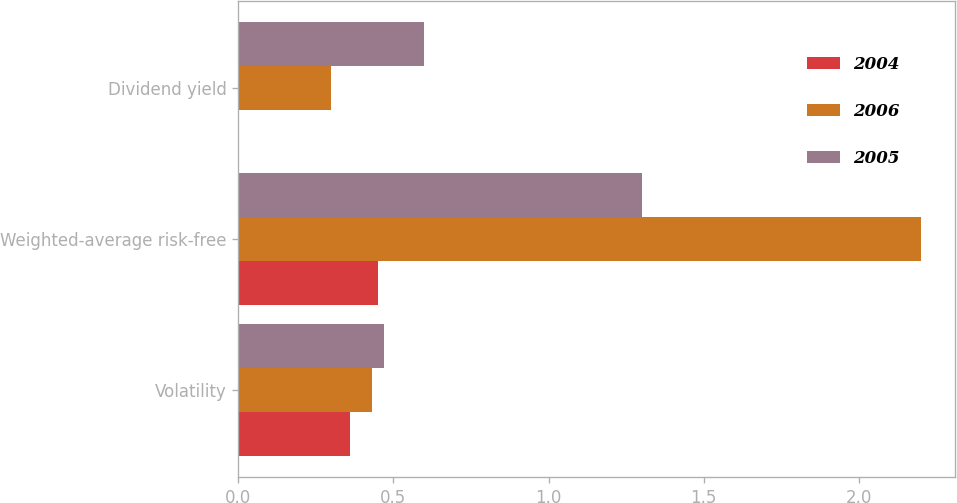Convert chart to OTSL. <chart><loc_0><loc_0><loc_500><loc_500><stacked_bar_chart><ecel><fcel>Volatility<fcel>Weighted-average risk-free<fcel>Dividend yield<nl><fcel>2004<fcel>0.36<fcel>0.45<fcel>0<nl><fcel>2006<fcel>0.43<fcel>2.2<fcel>0.3<nl><fcel>2005<fcel>0.47<fcel>1.3<fcel>0.6<nl></chart> 